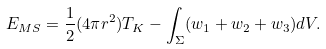<formula> <loc_0><loc_0><loc_500><loc_500>E _ { M S } = \frac { 1 } { 2 } ( 4 \pi r ^ { 2 } ) T _ { K } - \int _ { \Sigma } ( w _ { 1 } + w _ { 2 } + w _ { 3 } ) d V .</formula> 